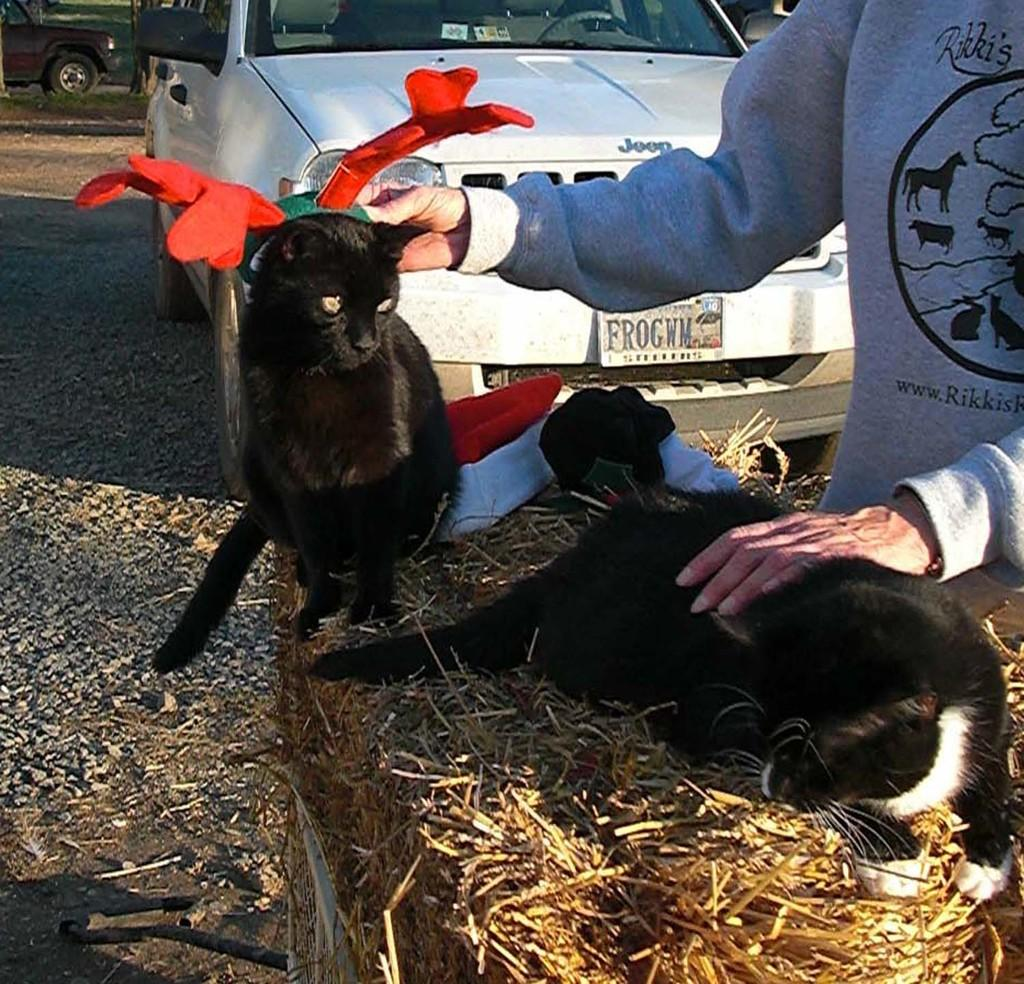Who is present in the image? There is a person in the image. What is the person holding? The person is holding cats. Can you describe the cats in the image? One of the cats is wearing a cap, and the other cat is lying on dry grass. What can be seen in the background of the image? There are vehicles visible in the background of the image. How well can the person hear the cats purring in the image? The image does not provide information about the person's ability to hear the cats purring, so it cannot be determined from the image. 